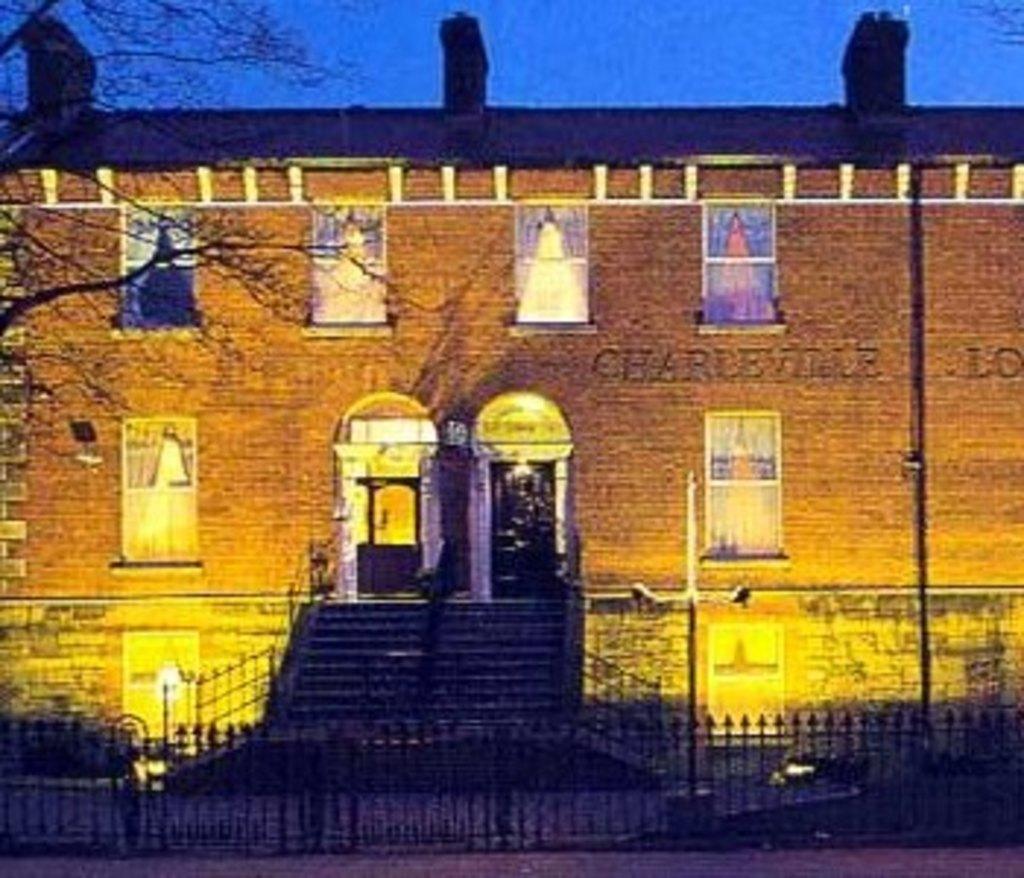Could you give a brief overview of what you see in this image? In this image we can see a building, fence, poles, pictures, and branches. In the background there is sky. 